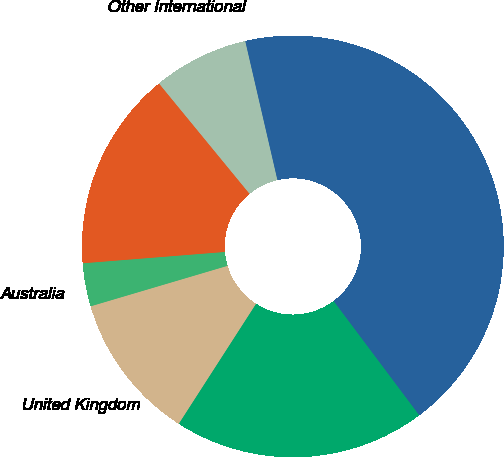Convert chart. <chart><loc_0><loc_0><loc_500><loc_500><pie_chart><fcel>United States<fcel>United Kingdom<fcel>Australia<fcel>Other Europe<fcel>Other International<fcel>Total Revenues<nl><fcel>19.34%<fcel>11.32%<fcel>3.31%<fcel>15.33%<fcel>7.32%<fcel>43.39%<nl></chart> 